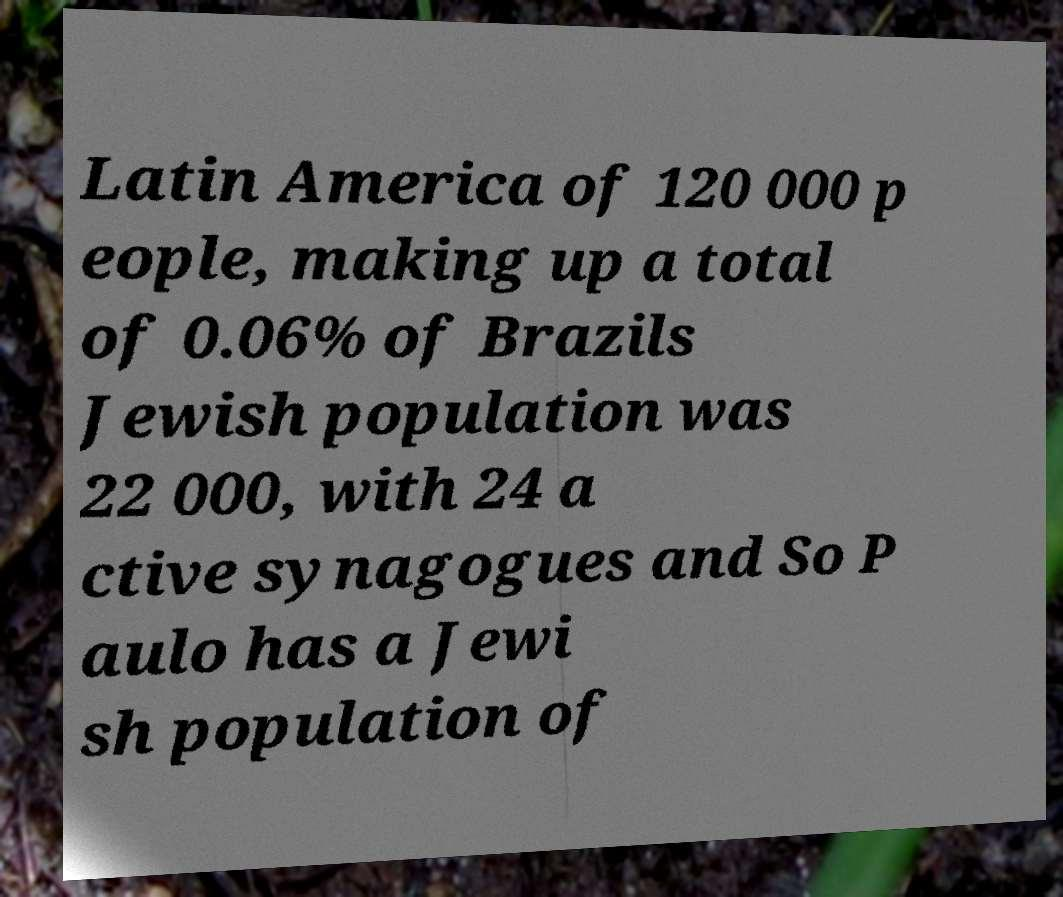Please read and relay the text visible in this image. What does it say? Latin America of 120 000 p eople, making up a total of 0.06% of Brazils Jewish population was 22 000, with 24 a ctive synagogues and So P aulo has a Jewi sh population of 